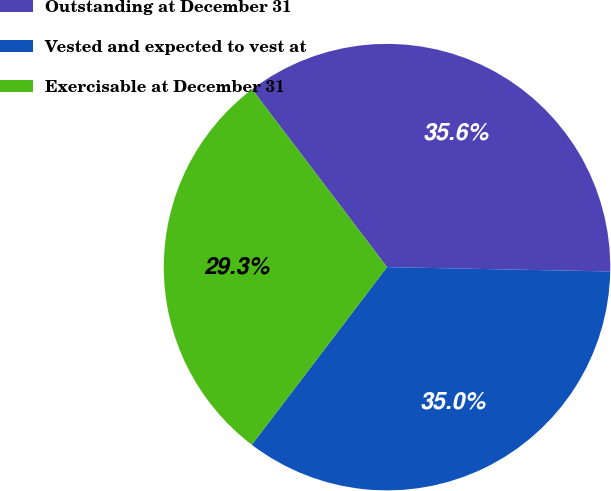<chart> <loc_0><loc_0><loc_500><loc_500><pie_chart><fcel>Outstanding at December 31<fcel>Vested and expected to vest at<fcel>Exercisable at December 31<nl><fcel>35.64%<fcel>35.05%<fcel>29.31%<nl></chart> 